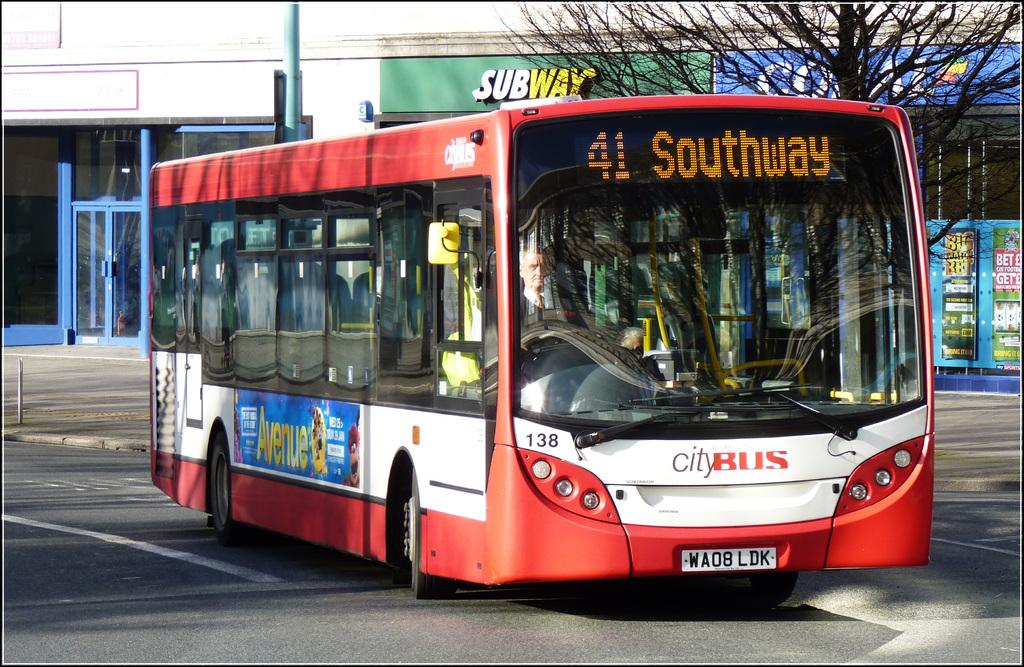What is the main subject in the center of the image? There is a bus in the center of the image. Where is the bus located? The bus is on the road. What can be seen in the background of the image? There are stores, a tree, boards, and poles visible in the background of the image. What color is the fish swimming in the image? There is no fish present in the image. How many bananas are hanging from the tree in the image? There is no tree with bananas in the image; there is only a single tree visible in the background. 